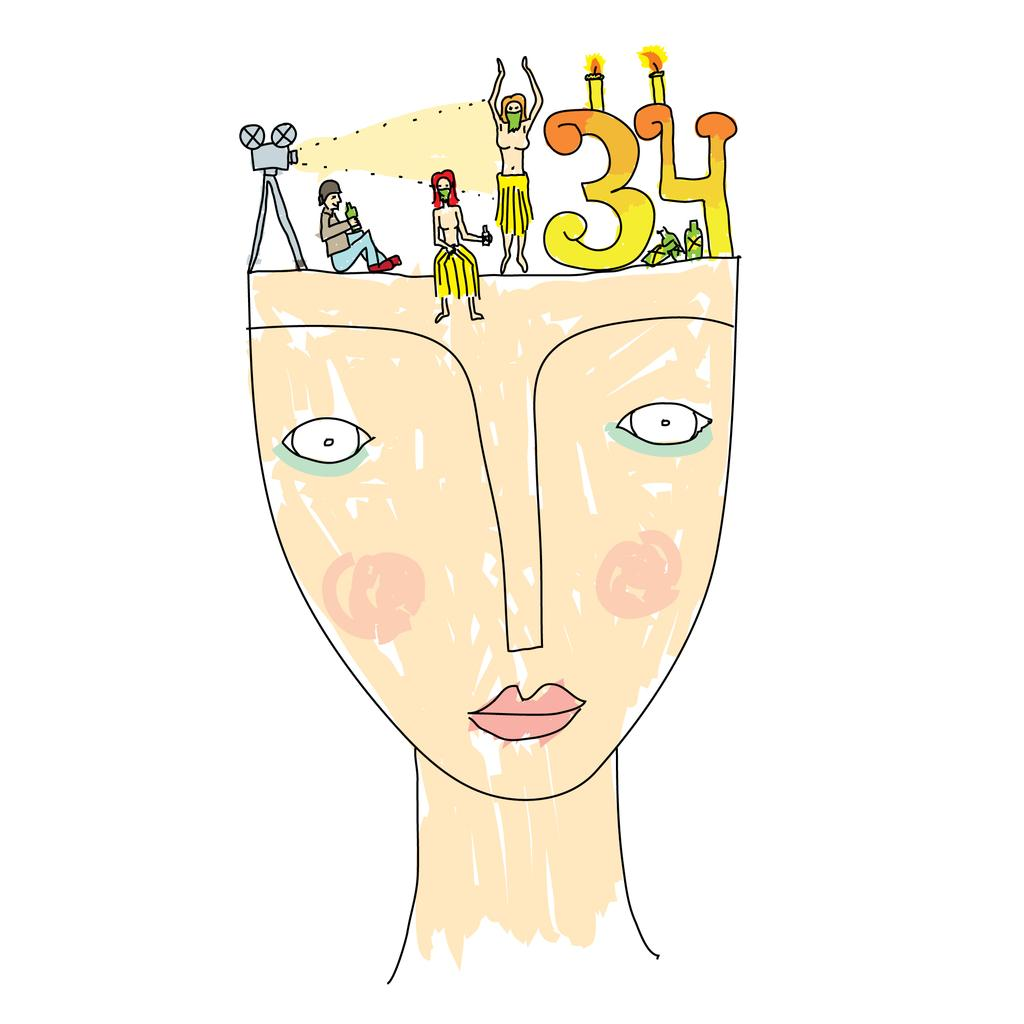What type of image is depicted in the drawing? The image is a drawing of an animated image. What type of trousers is the animated character wearing in the afternoon? There is no animated character or trousers present in the image, as it is a drawing of an animated image, not an actual animated scene. 